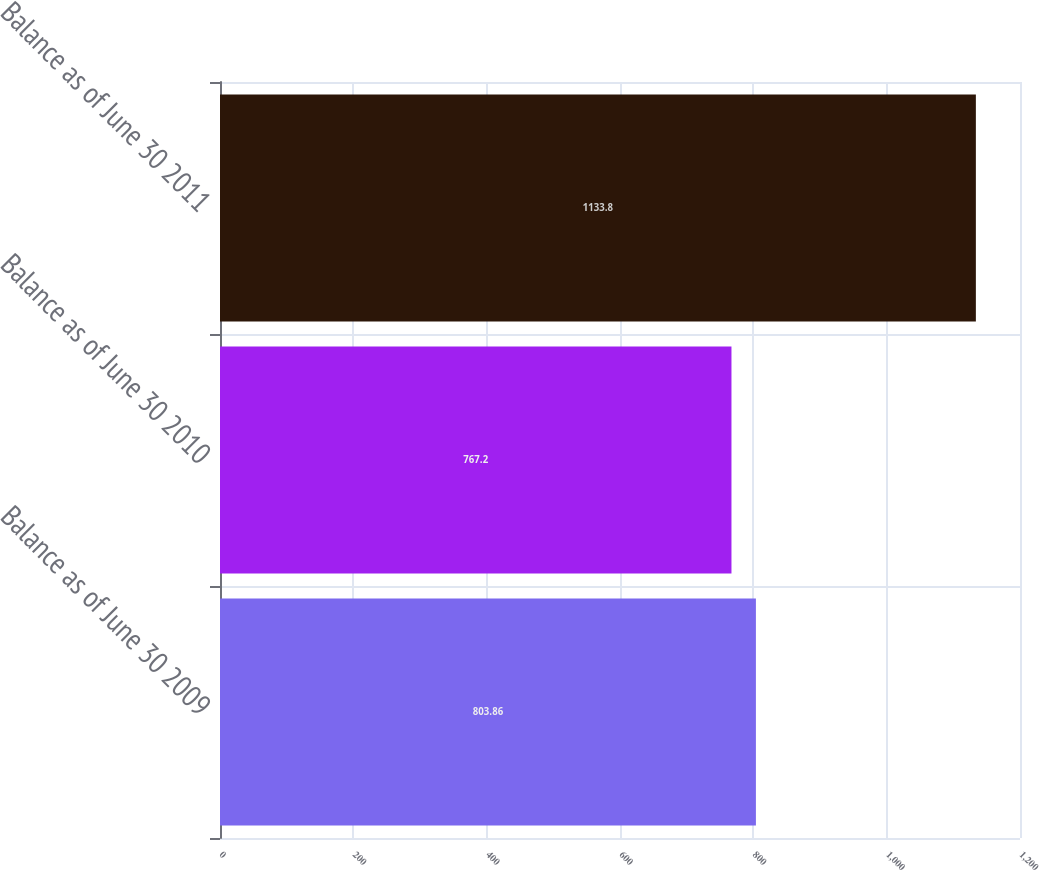Convert chart. <chart><loc_0><loc_0><loc_500><loc_500><bar_chart><fcel>Balance as of June 30 2009<fcel>Balance as of June 30 2010<fcel>Balance as of June 30 2011<nl><fcel>803.86<fcel>767.2<fcel>1133.8<nl></chart> 